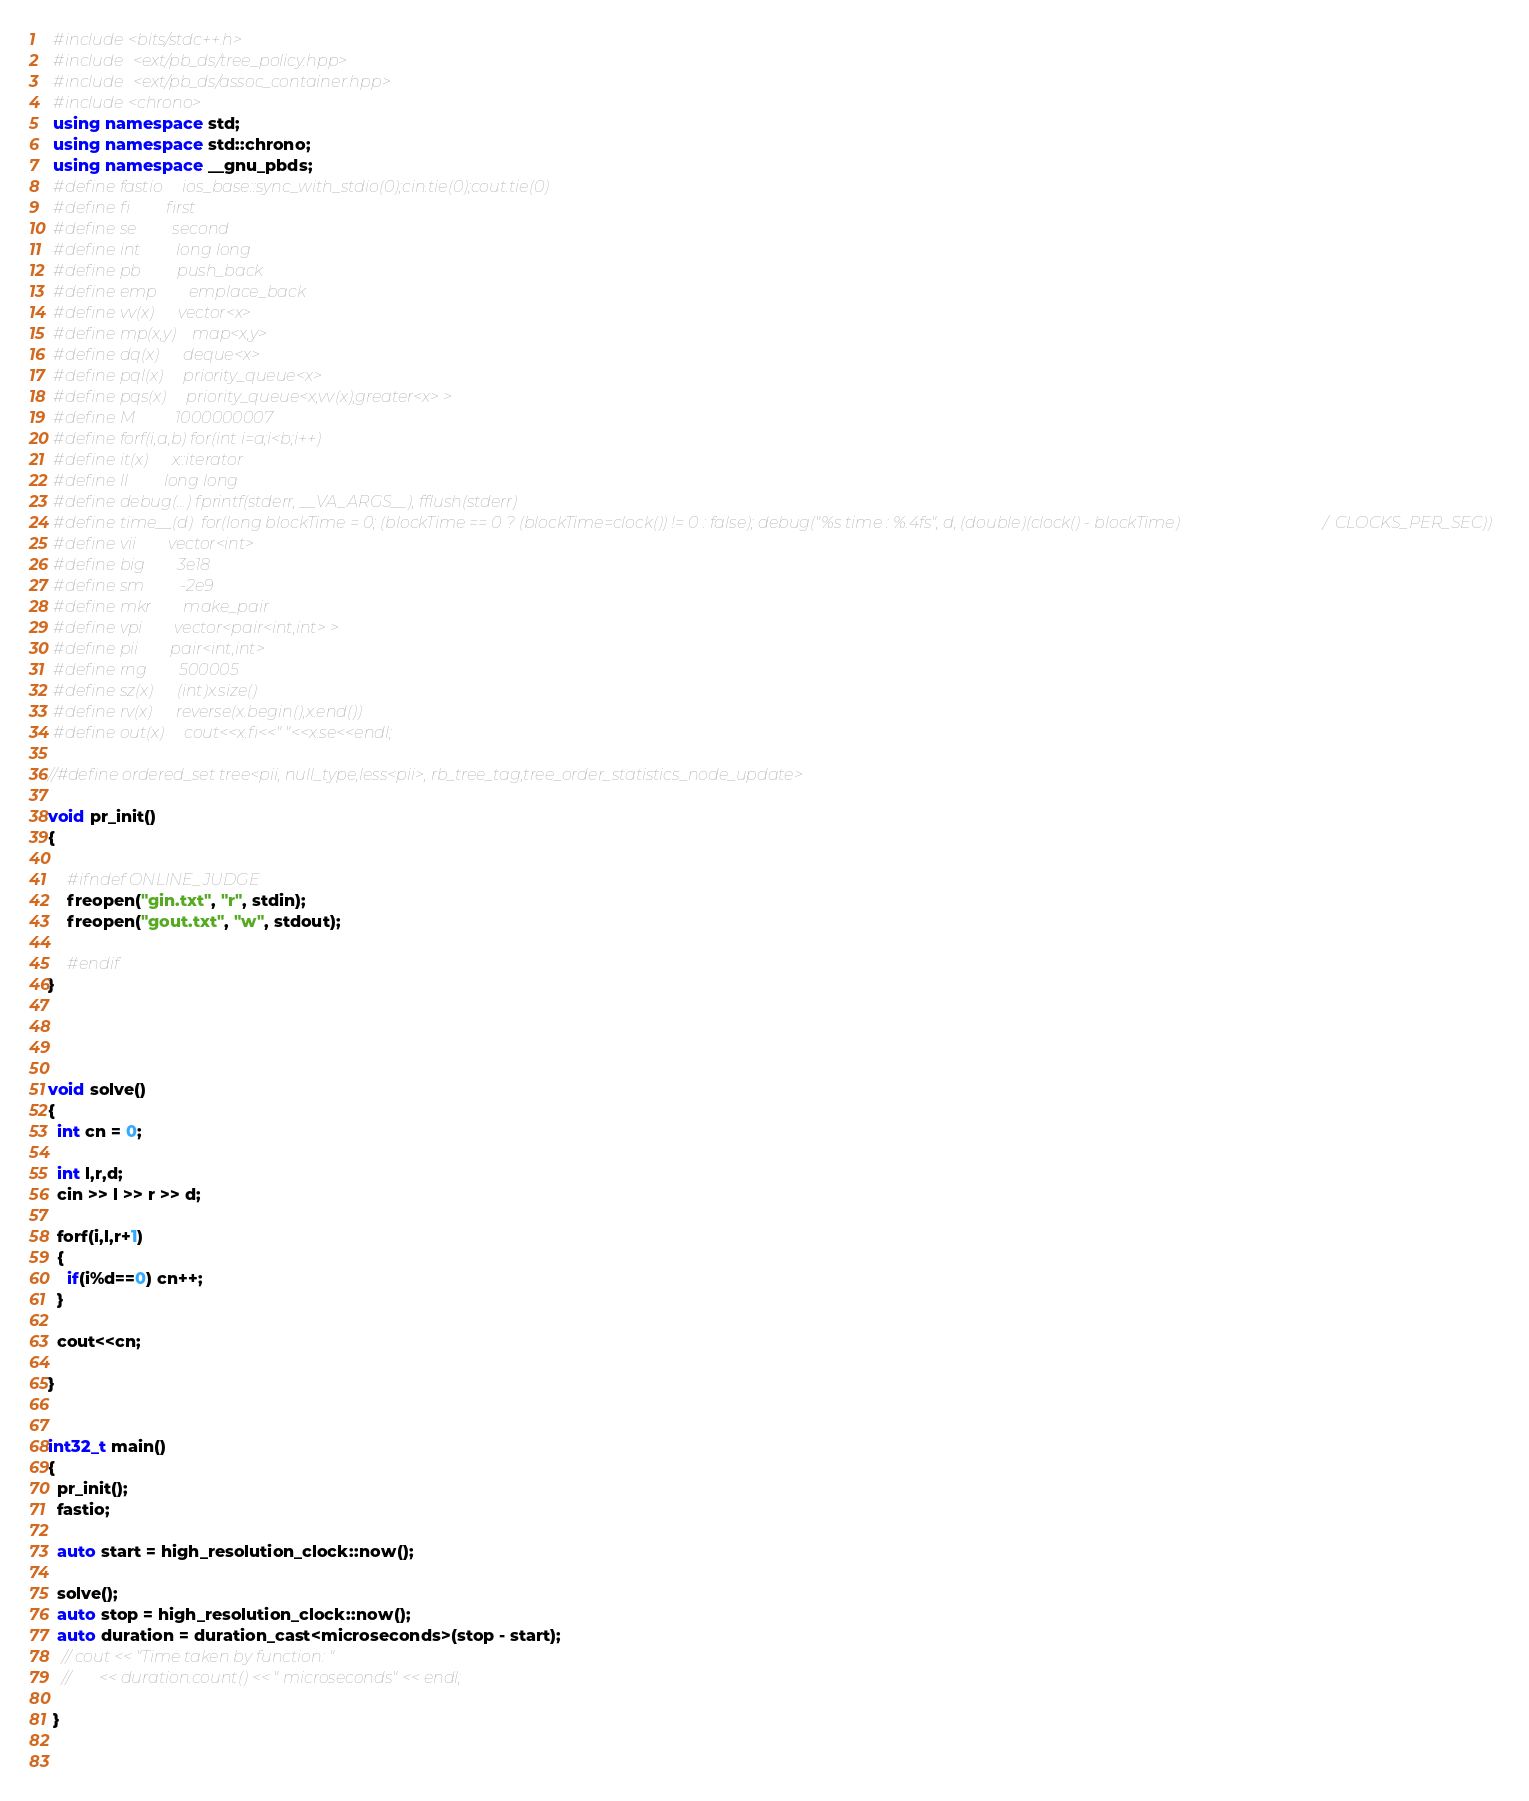<code> <loc_0><loc_0><loc_500><loc_500><_C++_> #include<bits/stdc++.h>
 #include <ext/pb_ds/tree_policy.hpp>
 #include <ext/pb_ds/assoc_container.hpp>
 #include<chrono>
 using namespace std;
 using namespace std::chrono;      
 using namespace __gnu_pbds; 
 #define fastio     ios_base::sync_with_stdio(0);cin.tie(0);cout.tie(0)
 #define fi         first
 #define se         second
 #define int         long long 
 #define pb         push_back
 #define emp        emplace_back
 #define vv(x)      vector<x>
 #define mp(x,y)    map<x,y>
 #define dq(x)      deque<x>
 #define pql(x)     priority_queue<x>
 #define pqs(x)     priority_queue<x,vv(x),greater<x> >
 #define M          1000000007
 #define forf(i,a,b) for(int i=a;i<b;i++)
 #define it(x)      x::iterator
 #define ll         long long 
 #define debug(...) fprintf(stderr, __VA_ARGS__), fflush(stderr)
 #define time__(d)  for(long blockTime = 0; (blockTime == 0 ? (blockTime=clock()) != 0 : false); debug("%s time : %.4fs", d, (double)(clock() - blockTime) / CLOCKS_PER_SEC))
 #define vii        vector<int>
 #define big        3e18
 #define sm         -2e9
 #define mkr        make_pair
 #define vpi        vector<pair<int,int> >
 #define pii        pair<int,int>
 #define rng        500005
 #define sz(x)      (int)x.size()
 #define rv(x)      reverse(x.begin(),x.end())
 #define out(x)     cout<<x.fi<<" "<<x.se<<endl;

//#define ordered_set tree<pii, null_type,less<pii>, rb_tree_tag,tree_order_statistics_node_update> 
  
void pr_init()
{
   
    #ifndef ONLINE_JUDGE
    freopen("gin.txt", "r", stdin);
    freopen("gout.txt", "w", stdout);
   
    #endif
}




void solve()
{
  int cn = 0;

  int l,r,d;
  cin >> l >> r >> d;

  forf(i,l,r+1)
  {
    if(i%d==0) cn++;
  }

  cout<<cn;

}


int32_t main()
{
  pr_init();
  fastio;
  
  auto start = high_resolution_clock::now(); 
 
  solve();
  auto stop = high_resolution_clock::now();
  auto duration = duration_cast<microseconds>(stop - start); 
   // cout << "Time taken by function: "
   //       << duration.count() << " microseconds" << endl; 

 }
      
      </code> 